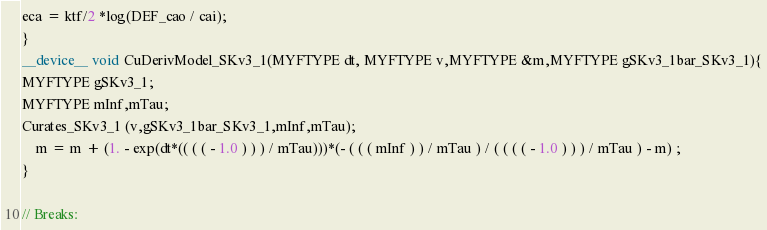Convert code to text. <code><loc_0><loc_0><loc_500><loc_500><_Cuda_>eca = ktf/2 *log(DEF_cao / cai);
}
__device__ void CuDerivModel_SKv3_1(MYFTYPE dt, MYFTYPE v,MYFTYPE &m,MYFTYPE gSKv3_1bar_SKv3_1){
MYFTYPE gSKv3_1;
MYFTYPE mInf,mTau;
Curates_SKv3_1 (v,gSKv3_1bar_SKv3_1,mInf,mTau);
    m = m + (1. - exp(dt*(( ( ( - 1.0 ) ) ) / mTau)))*(- ( ( ( mInf ) ) / mTau ) / ( ( ( ( - 1.0 ) ) ) / mTau ) - m) ;
}

// Breaks:

</code> 